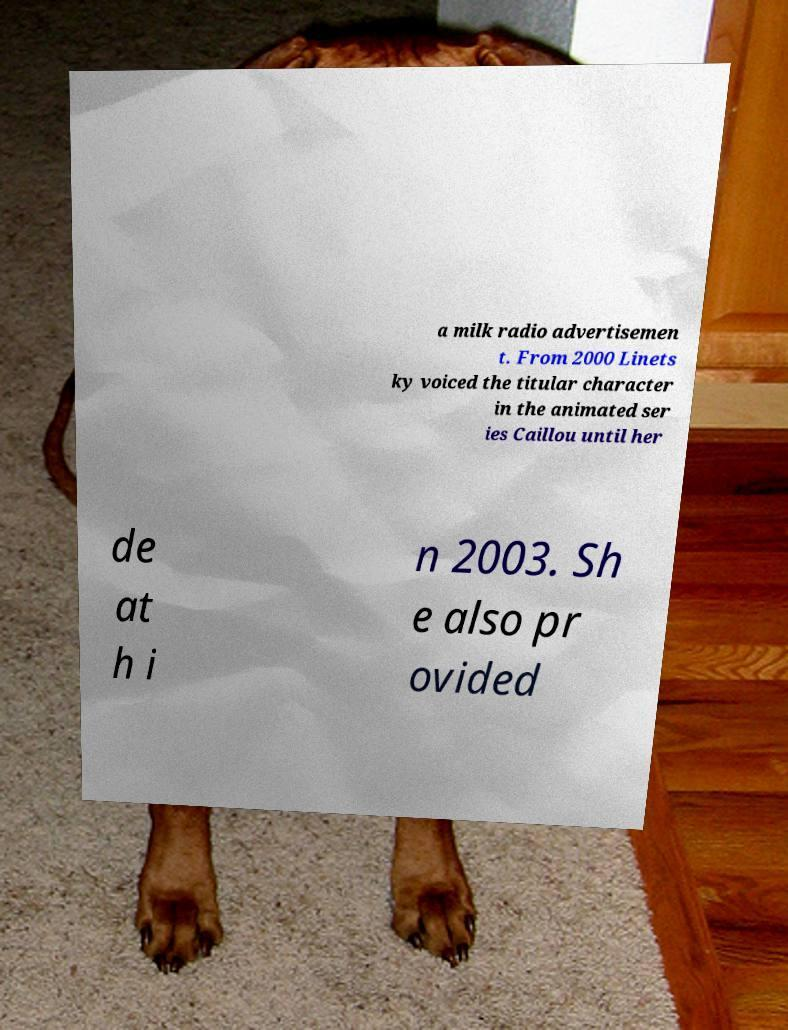Could you extract and type out the text from this image? a milk radio advertisemen t. From 2000 Linets ky voiced the titular character in the animated ser ies Caillou until her de at h i n 2003. Sh e also pr ovided 